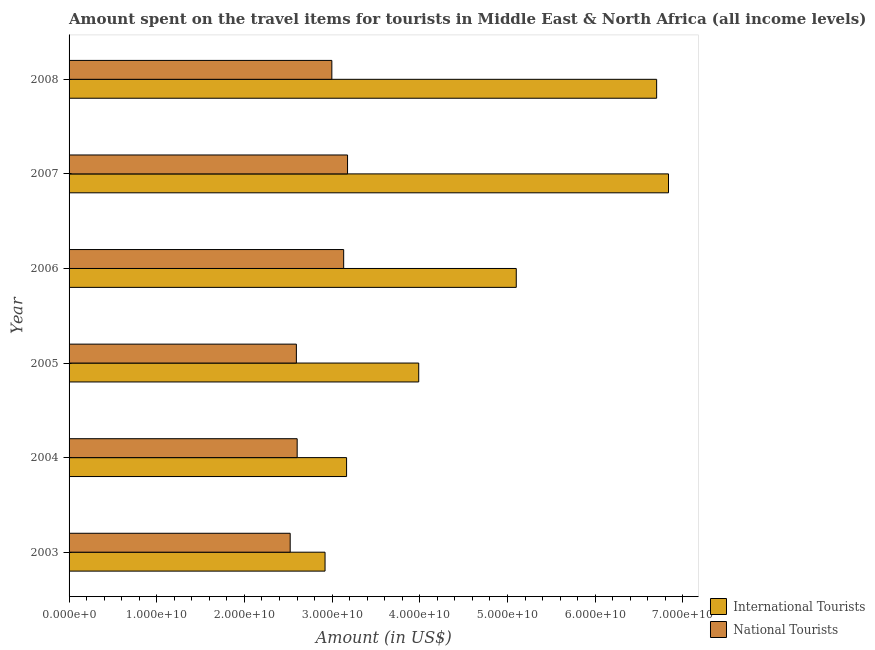How many different coloured bars are there?
Offer a terse response. 2. How many groups of bars are there?
Give a very brief answer. 6. Are the number of bars on each tick of the Y-axis equal?
Offer a very short reply. Yes. How many bars are there on the 6th tick from the bottom?
Your answer should be very brief. 2. What is the label of the 6th group of bars from the top?
Ensure brevity in your answer.  2003. What is the amount spent on travel items of international tourists in 2006?
Ensure brevity in your answer.  5.10e+1. Across all years, what is the maximum amount spent on travel items of international tourists?
Your response must be concise. 6.84e+1. Across all years, what is the minimum amount spent on travel items of international tourists?
Offer a very short reply. 2.92e+1. In which year was the amount spent on travel items of national tourists minimum?
Provide a short and direct response. 2003. What is the total amount spent on travel items of national tourists in the graph?
Your answer should be compact. 1.70e+11. What is the difference between the amount spent on travel items of international tourists in 2003 and that in 2007?
Provide a succinct answer. -3.92e+1. What is the difference between the amount spent on travel items of national tourists in 2008 and the amount spent on travel items of international tourists in 2006?
Offer a very short reply. -2.10e+1. What is the average amount spent on travel items of international tourists per year?
Offer a very short reply. 4.78e+1. In the year 2004, what is the difference between the amount spent on travel items of national tourists and amount spent on travel items of international tourists?
Your answer should be compact. -5.63e+09. In how many years, is the amount spent on travel items of national tourists greater than 50000000000 US$?
Your response must be concise. 0. What is the ratio of the amount spent on travel items of international tourists in 2003 to that in 2005?
Offer a very short reply. 0.73. Is the difference between the amount spent on travel items of national tourists in 2003 and 2004 greater than the difference between the amount spent on travel items of international tourists in 2003 and 2004?
Provide a short and direct response. Yes. What is the difference between the highest and the second highest amount spent on travel items of national tourists?
Ensure brevity in your answer.  4.43e+08. What is the difference between the highest and the lowest amount spent on travel items of international tourists?
Provide a succinct answer. 3.92e+1. Is the sum of the amount spent on travel items of international tourists in 2005 and 2006 greater than the maximum amount spent on travel items of national tourists across all years?
Make the answer very short. Yes. What does the 1st bar from the top in 2003 represents?
Keep it short and to the point. National Tourists. What does the 1st bar from the bottom in 2008 represents?
Offer a terse response. International Tourists. How many bars are there?
Ensure brevity in your answer.  12. How many years are there in the graph?
Offer a terse response. 6. What is the difference between two consecutive major ticks on the X-axis?
Offer a terse response. 1.00e+1. Are the values on the major ticks of X-axis written in scientific E-notation?
Your answer should be compact. Yes. Does the graph contain any zero values?
Offer a very short reply. No. Does the graph contain grids?
Provide a succinct answer. No. What is the title of the graph?
Keep it short and to the point. Amount spent on the travel items for tourists in Middle East & North Africa (all income levels). What is the Amount (in US$) in International Tourists in 2003?
Your response must be concise. 2.92e+1. What is the Amount (in US$) of National Tourists in 2003?
Your response must be concise. 2.52e+1. What is the Amount (in US$) in International Tourists in 2004?
Provide a succinct answer. 3.16e+1. What is the Amount (in US$) in National Tourists in 2004?
Make the answer very short. 2.60e+1. What is the Amount (in US$) in International Tourists in 2005?
Ensure brevity in your answer.  3.99e+1. What is the Amount (in US$) of National Tourists in 2005?
Your response must be concise. 2.59e+1. What is the Amount (in US$) in International Tourists in 2006?
Give a very brief answer. 5.10e+1. What is the Amount (in US$) of National Tourists in 2006?
Your response must be concise. 3.13e+1. What is the Amount (in US$) in International Tourists in 2007?
Keep it short and to the point. 6.84e+1. What is the Amount (in US$) of National Tourists in 2007?
Provide a short and direct response. 3.18e+1. What is the Amount (in US$) of International Tourists in 2008?
Your response must be concise. 6.70e+1. What is the Amount (in US$) in National Tourists in 2008?
Your answer should be very brief. 3.00e+1. Across all years, what is the maximum Amount (in US$) of International Tourists?
Your response must be concise. 6.84e+1. Across all years, what is the maximum Amount (in US$) in National Tourists?
Offer a very short reply. 3.18e+1. Across all years, what is the minimum Amount (in US$) in International Tourists?
Keep it short and to the point. 2.92e+1. Across all years, what is the minimum Amount (in US$) of National Tourists?
Offer a very short reply. 2.52e+1. What is the total Amount (in US$) in International Tourists in the graph?
Your answer should be very brief. 2.87e+11. What is the total Amount (in US$) in National Tourists in the graph?
Offer a very short reply. 1.70e+11. What is the difference between the Amount (in US$) of International Tourists in 2003 and that in 2004?
Make the answer very short. -2.45e+09. What is the difference between the Amount (in US$) of National Tourists in 2003 and that in 2004?
Your response must be concise. -7.97e+08. What is the difference between the Amount (in US$) in International Tourists in 2003 and that in 2005?
Your response must be concise. -1.07e+1. What is the difference between the Amount (in US$) in National Tourists in 2003 and that in 2005?
Your answer should be compact. -7.07e+08. What is the difference between the Amount (in US$) of International Tourists in 2003 and that in 2006?
Your response must be concise. -2.18e+1. What is the difference between the Amount (in US$) in National Tourists in 2003 and that in 2006?
Provide a short and direct response. -6.10e+09. What is the difference between the Amount (in US$) of International Tourists in 2003 and that in 2007?
Your answer should be very brief. -3.92e+1. What is the difference between the Amount (in US$) of National Tourists in 2003 and that in 2007?
Ensure brevity in your answer.  -6.54e+09. What is the difference between the Amount (in US$) of International Tourists in 2003 and that in 2008?
Ensure brevity in your answer.  -3.78e+1. What is the difference between the Amount (in US$) in National Tourists in 2003 and that in 2008?
Provide a succinct answer. -4.75e+09. What is the difference between the Amount (in US$) in International Tourists in 2004 and that in 2005?
Offer a very short reply. -8.23e+09. What is the difference between the Amount (in US$) in National Tourists in 2004 and that in 2005?
Provide a succinct answer. 9.04e+07. What is the difference between the Amount (in US$) in International Tourists in 2004 and that in 2006?
Your answer should be very brief. -1.94e+1. What is the difference between the Amount (in US$) of National Tourists in 2004 and that in 2006?
Offer a very short reply. -5.30e+09. What is the difference between the Amount (in US$) in International Tourists in 2004 and that in 2007?
Make the answer very short. -3.67e+1. What is the difference between the Amount (in US$) in National Tourists in 2004 and that in 2007?
Give a very brief answer. -5.75e+09. What is the difference between the Amount (in US$) in International Tourists in 2004 and that in 2008?
Ensure brevity in your answer.  -3.54e+1. What is the difference between the Amount (in US$) in National Tourists in 2004 and that in 2008?
Your answer should be very brief. -3.95e+09. What is the difference between the Amount (in US$) of International Tourists in 2005 and that in 2006?
Keep it short and to the point. -1.11e+1. What is the difference between the Amount (in US$) of National Tourists in 2005 and that in 2006?
Your answer should be very brief. -5.39e+09. What is the difference between the Amount (in US$) in International Tourists in 2005 and that in 2007?
Your answer should be compact. -2.85e+1. What is the difference between the Amount (in US$) in National Tourists in 2005 and that in 2007?
Provide a succinct answer. -5.84e+09. What is the difference between the Amount (in US$) of International Tourists in 2005 and that in 2008?
Provide a short and direct response. -2.71e+1. What is the difference between the Amount (in US$) of National Tourists in 2005 and that in 2008?
Ensure brevity in your answer.  -4.04e+09. What is the difference between the Amount (in US$) in International Tourists in 2006 and that in 2007?
Make the answer very short. -1.74e+1. What is the difference between the Amount (in US$) of National Tourists in 2006 and that in 2007?
Ensure brevity in your answer.  -4.43e+08. What is the difference between the Amount (in US$) of International Tourists in 2006 and that in 2008?
Ensure brevity in your answer.  -1.60e+1. What is the difference between the Amount (in US$) in National Tourists in 2006 and that in 2008?
Your response must be concise. 1.35e+09. What is the difference between the Amount (in US$) of International Tourists in 2007 and that in 2008?
Ensure brevity in your answer.  1.35e+09. What is the difference between the Amount (in US$) of National Tourists in 2007 and that in 2008?
Offer a very short reply. 1.79e+09. What is the difference between the Amount (in US$) in International Tourists in 2003 and the Amount (in US$) in National Tourists in 2004?
Give a very brief answer. 3.18e+09. What is the difference between the Amount (in US$) of International Tourists in 2003 and the Amount (in US$) of National Tourists in 2005?
Your response must be concise. 3.27e+09. What is the difference between the Amount (in US$) in International Tourists in 2003 and the Amount (in US$) in National Tourists in 2006?
Your answer should be very brief. -2.12e+09. What is the difference between the Amount (in US$) in International Tourists in 2003 and the Amount (in US$) in National Tourists in 2007?
Your answer should be compact. -2.57e+09. What is the difference between the Amount (in US$) in International Tourists in 2003 and the Amount (in US$) in National Tourists in 2008?
Give a very brief answer. -7.74e+08. What is the difference between the Amount (in US$) in International Tourists in 2004 and the Amount (in US$) in National Tourists in 2005?
Give a very brief answer. 5.72e+09. What is the difference between the Amount (in US$) in International Tourists in 2004 and the Amount (in US$) in National Tourists in 2006?
Your answer should be compact. 3.31e+08. What is the difference between the Amount (in US$) of International Tourists in 2004 and the Amount (in US$) of National Tourists in 2007?
Offer a very short reply. -1.12e+08. What is the difference between the Amount (in US$) in International Tourists in 2004 and the Amount (in US$) in National Tourists in 2008?
Keep it short and to the point. 1.68e+09. What is the difference between the Amount (in US$) of International Tourists in 2005 and the Amount (in US$) of National Tourists in 2006?
Ensure brevity in your answer.  8.56e+09. What is the difference between the Amount (in US$) in International Tourists in 2005 and the Amount (in US$) in National Tourists in 2007?
Give a very brief answer. 8.12e+09. What is the difference between the Amount (in US$) in International Tourists in 2005 and the Amount (in US$) in National Tourists in 2008?
Your answer should be very brief. 9.91e+09. What is the difference between the Amount (in US$) in International Tourists in 2006 and the Amount (in US$) in National Tourists in 2007?
Offer a very short reply. 1.92e+1. What is the difference between the Amount (in US$) in International Tourists in 2006 and the Amount (in US$) in National Tourists in 2008?
Make the answer very short. 2.10e+1. What is the difference between the Amount (in US$) of International Tourists in 2007 and the Amount (in US$) of National Tourists in 2008?
Provide a short and direct response. 3.84e+1. What is the average Amount (in US$) in International Tourists per year?
Provide a succinct answer. 4.78e+1. What is the average Amount (in US$) in National Tourists per year?
Give a very brief answer. 2.84e+1. In the year 2003, what is the difference between the Amount (in US$) in International Tourists and Amount (in US$) in National Tourists?
Give a very brief answer. 3.98e+09. In the year 2004, what is the difference between the Amount (in US$) in International Tourists and Amount (in US$) in National Tourists?
Provide a succinct answer. 5.63e+09. In the year 2005, what is the difference between the Amount (in US$) in International Tourists and Amount (in US$) in National Tourists?
Ensure brevity in your answer.  1.40e+1. In the year 2006, what is the difference between the Amount (in US$) in International Tourists and Amount (in US$) in National Tourists?
Offer a very short reply. 1.97e+1. In the year 2007, what is the difference between the Amount (in US$) in International Tourists and Amount (in US$) in National Tourists?
Provide a succinct answer. 3.66e+1. In the year 2008, what is the difference between the Amount (in US$) in International Tourists and Amount (in US$) in National Tourists?
Give a very brief answer. 3.70e+1. What is the ratio of the Amount (in US$) in International Tourists in 2003 to that in 2004?
Ensure brevity in your answer.  0.92. What is the ratio of the Amount (in US$) in National Tourists in 2003 to that in 2004?
Your response must be concise. 0.97. What is the ratio of the Amount (in US$) in International Tourists in 2003 to that in 2005?
Your response must be concise. 0.73. What is the ratio of the Amount (in US$) in National Tourists in 2003 to that in 2005?
Offer a very short reply. 0.97. What is the ratio of the Amount (in US$) of International Tourists in 2003 to that in 2006?
Keep it short and to the point. 0.57. What is the ratio of the Amount (in US$) in National Tourists in 2003 to that in 2006?
Provide a succinct answer. 0.81. What is the ratio of the Amount (in US$) in International Tourists in 2003 to that in 2007?
Offer a very short reply. 0.43. What is the ratio of the Amount (in US$) in National Tourists in 2003 to that in 2007?
Your response must be concise. 0.79. What is the ratio of the Amount (in US$) of International Tourists in 2003 to that in 2008?
Offer a terse response. 0.44. What is the ratio of the Amount (in US$) in National Tourists in 2003 to that in 2008?
Give a very brief answer. 0.84. What is the ratio of the Amount (in US$) of International Tourists in 2004 to that in 2005?
Offer a very short reply. 0.79. What is the ratio of the Amount (in US$) of National Tourists in 2004 to that in 2005?
Offer a very short reply. 1. What is the ratio of the Amount (in US$) in International Tourists in 2004 to that in 2006?
Make the answer very short. 0.62. What is the ratio of the Amount (in US$) in National Tourists in 2004 to that in 2006?
Your response must be concise. 0.83. What is the ratio of the Amount (in US$) of International Tourists in 2004 to that in 2007?
Provide a short and direct response. 0.46. What is the ratio of the Amount (in US$) in National Tourists in 2004 to that in 2007?
Make the answer very short. 0.82. What is the ratio of the Amount (in US$) in International Tourists in 2004 to that in 2008?
Keep it short and to the point. 0.47. What is the ratio of the Amount (in US$) in National Tourists in 2004 to that in 2008?
Provide a succinct answer. 0.87. What is the ratio of the Amount (in US$) of International Tourists in 2005 to that in 2006?
Keep it short and to the point. 0.78. What is the ratio of the Amount (in US$) of National Tourists in 2005 to that in 2006?
Offer a very short reply. 0.83. What is the ratio of the Amount (in US$) of International Tourists in 2005 to that in 2007?
Your answer should be very brief. 0.58. What is the ratio of the Amount (in US$) in National Tourists in 2005 to that in 2007?
Offer a very short reply. 0.82. What is the ratio of the Amount (in US$) of International Tourists in 2005 to that in 2008?
Your answer should be compact. 0.6. What is the ratio of the Amount (in US$) in National Tourists in 2005 to that in 2008?
Your answer should be very brief. 0.86. What is the ratio of the Amount (in US$) in International Tourists in 2006 to that in 2007?
Provide a succinct answer. 0.75. What is the ratio of the Amount (in US$) of National Tourists in 2006 to that in 2007?
Offer a terse response. 0.99. What is the ratio of the Amount (in US$) in International Tourists in 2006 to that in 2008?
Your answer should be very brief. 0.76. What is the ratio of the Amount (in US$) in National Tourists in 2006 to that in 2008?
Provide a succinct answer. 1.04. What is the ratio of the Amount (in US$) of International Tourists in 2007 to that in 2008?
Ensure brevity in your answer.  1.02. What is the ratio of the Amount (in US$) of National Tourists in 2007 to that in 2008?
Offer a terse response. 1.06. What is the difference between the highest and the second highest Amount (in US$) in International Tourists?
Make the answer very short. 1.35e+09. What is the difference between the highest and the second highest Amount (in US$) in National Tourists?
Keep it short and to the point. 4.43e+08. What is the difference between the highest and the lowest Amount (in US$) of International Tourists?
Give a very brief answer. 3.92e+1. What is the difference between the highest and the lowest Amount (in US$) of National Tourists?
Provide a succinct answer. 6.54e+09. 